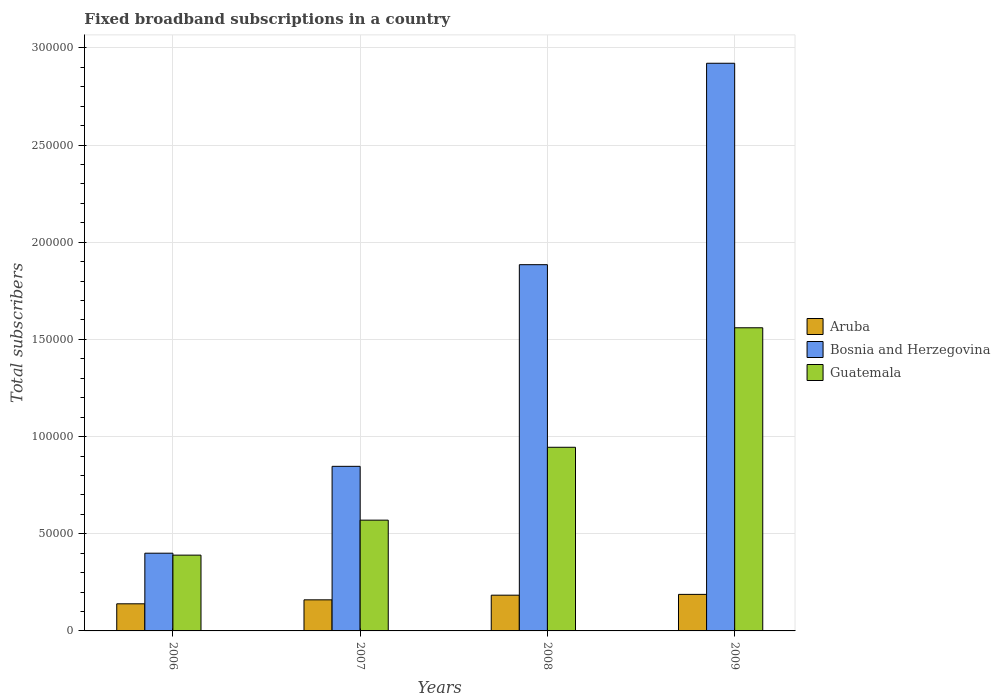How many different coloured bars are there?
Make the answer very short. 3. What is the label of the 4th group of bars from the left?
Offer a very short reply. 2009. In how many cases, is the number of bars for a given year not equal to the number of legend labels?
Keep it short and to the point. 0. What is the number of broadband subscriptions in Aruba in 2008?
Give a very brief answer. 1.84e+04. Across all years, what is the maximum number of broadband subscriptions in Aruba?
Your answer should be very brief. 1.88e+04. Across all years, what is the minimum number of broadband subscriptions in Aruba?
Provide a succinct answer. 1.40e+04. In which year was the number of broadband subscriptions in Aruba maximum?
Your answer should be very brief. 2009. In which year was the number of broadband subscriptions in Guatemala minimum?
Give a very brief answer. 2006. What is the total number of broadband subscriptions in Bosnia and Herzegovina in the graph?
Make the answer very short. 6.05e+05. What is the difference between the number of broadband subscriptions in Bosnia and Herzegovina in 2006 and that in 2007?
Make the answer very short. -4.47e+04. What is the difference between the number of broadband subscriptions in Aruba in 2009 and the number of broadband subscriptions in Bosnia and Herzegovina in 2006?
Your answer should be very brief. -2.12e+04. What is the average number of broadband subscriptions in Guatemala per year?
Ensure brevity in your answer.  8.66e+04. In the year 2009, what is the difference between the number of broadband subscriptions in Bosnia and Herzegovina and number of broadband subscriptions in Guatemala?
Keep it short and to the point. 1.36e+05. What is the ratio of the number of broadband subscriptions in Bosnia and Herzegovina in 2006 to that in 2007?
Your response must be concise. 0.47. What is the difference between the highest and the second highest number of broadband subscriptions in Guatemala?
Your answer should be compact. 6.15e+04. What is the difference between the highest and the lowest number of broadband subscriptions in Bosnia and Herzegovina?
Ensure brevity in your answer.  2.52e+05. What does the 1st bar from the left in 2009 represents?
Offer a very short reply. Aruba. What does the 3rd bar from the right in 2007 represents?
Your answer should be very brief. Aruba. How many bars are there?
Offer a very short reply. 12. Are all the bars in the graph horizontal?
Ensure brevity in your answer.  No. How many years are there in the graph?
Offer a terse response. 4. Are the values on the major ticks of Y-axis written in scientific E-notation?
Keep it short and to the point. No. How are the legend labels stacked?
Make the answer very short. Vertical. What is the title of the graph?
Your answer should be compact. Fixed broadband subscriptions in a country. Does "Jamaica" appear as one of the legend labels in the graph?
Your answer should be compact. No. What is the label or title of the X-axis?
Ensure brevity in your answer.  Years. What is the label or title of the Y-axis?
Offer a very short reply. Total subscribers. What is the Total subscribers of Aruba in 2006?
Provide a succinct answer. 1.40e+04. What is the Total subscribers of Bosnia and Herzegovina in 2006?
Your answer should be compact. 4.00e+04. What is the Total subscribers of Guatemala in 2006?
Your response must be concise. 3.90e+04. What is the Total subscribers of Aruba in 2007?
Make the answer very short. 1.60e+04. What is the Total subscribers of Bosnia and Herzegovina in 2007?
Offer a very short reply. 8.47e+04. What is the Total subscribers of Guatemala in 2007?
Make the answer very short. 5.70e+04. What is the Total subscribers in Aruba in 2008?
Keep it short and to the point. 1.84e+04. What is the Total subscribers in Bosnia and Herzegovina in 2008?
Your answer should be compact. 1.88e+05. What is the Total subscribers of Guatemala in 2008?
Give a very brief answer. 9.45e+04. What is the Total subscribers in Aruba in 2009?
Ensure brevity in your answer.  1.88e+04. What is the Total subscribers in Bosnia and Herzegovina in 2009?
Offer a very short reply. 2.92e+05. What is the Total subscribers of Guatemala in 2009?
Offer a very short reply. 1.56e+05. Across all years, what is the maximum Total subscribers of Aruba?
Ensure brevity in your answer.  1.88e+04. Across all years, what is the maximum Total subscribers in Bosnia and Herzegovina?
Ensure brevity in your answer.  2.92e+05. Across all years, what is the maximum Total subscribers of Guatemala?
Your answer should be compact. 1.56e+05. Across all years, what is the minimum Total subscribers in Aruba?
Offer a very short reply. 1.40e+04. Across all years, what is the minimum Total subscribers of Bosnia and Herzegovina?
Give a very brief answer. 4.00e+04. Across all years, what is the minimum Total subscribers in Guatemala?
Provide a succinct answer. 3.90e+04. What is the total Total subscribers in Aruba in the graph?
Give a very brief answer. 6.71e+04. What is the total Total subscribers in Bosnia and Herzegovina in the graph?
Ensure brevity in your answer.  6.05e+05. What is the total Total subscribers in Guatemala in the graph?
Provide a succinct answer. 3.46e+05. What is the difference between the Total subscribers in Aruba in 2006 and that in 2007?
Keep it short and to the point. -2043. What is the difference between the Total subscribers of Bosnia and Herzegovina in 2006 and that in 2007?
Provide a short and direct response. -4.47e+04. What is the difference between the Total subscribers of Guatemala in 2006 and that in 2007?
Your response must be concise. -1.80e+04. What is the difference between the Total subscribers in Aruba in 2006 and that in 2008?
Make the answer very short. -4443. What is the difference between the Total subscribers of Bosnia and Herzegovina in 2006 and that in 2008?
Keep it short and to the point. -1.48e+05. What is the difference between the Total subscribers in Guatemala in 2006 and that in 2008?
Your response must be concise. -5.55e+04. What is the difference between the Total subscribers of Aruba in 2006 and that in 2009?
Offer a terse response. -4847. What is the difference between the Total subscribers in Bosnia and Herzegovina in 2006 and that in 2009?
Offer a very short reply. -2.52e+05. What is the difference between the Total subscribers of Guatemala in 2006 and that in 2009?
Offer a terse response. -1.17e+05. What is the difference between the Total subscribers in Aruba in 2007 and that in 2008?
Your answer should be very brief. -2400. What is the difference between the Total subscribers of Bosnia and Herzegovina in 2007 and that in 2008?
Your response must be concise. -1.04e+05. What is the difference between the Total subscribers of Guatemala in 2007 and that in 2008?
Offer a very short reply. -3.75e+04. What is the difference between the Total subscribers in Aruba in 2007 and that in 2009?
Your answer should be compact. -2804. What is the difference between the Total subscribers in Bosnia and Herzegovina in 2007 and that in 2009?
Make the answer very short. -2.07e+05. What is the difference between the Total subscribers in Guatemala in 2007 and that in 2009?
Offer a very short reply. -9.90e+04. What is the difference between the Total subscribers of Aruba in 2008 and that in 2009?
Your response must be concise. -404. What is the difference between the Total subscribers in Bosnia and Herzegovina in 2008 and that in 2009?
Give a very brief answer. -1.04e+05. What is the difference between the Total subscribers of Guatemala in 2008 and that in 2009?
Provide a short and direct response. -6.15e+04. What is the difference between the Total subscribers of Aruba in 2006 and the Total subscribers of Bosnia and Herzegovina in 2007?
Your answer should be compact. -7.07e+04. What is the difference between the Total subscribers in Aruba in 2006 and the Total subscribers in Guatemala in 2007?
Provide a short and direct response. -4.30e+04. What is the difference between the Total subscribers of Bosnia and Herzegovina in 2006 and the Total subscribers of Guatemala in 2007?
Give a very brief answer. -1.70e+04. What is the difference between the Total subscribers of Aruba in 2006 and the Total subscribers of Bosnia and Herzegovina in 2008?
Offer a terse response. -1.75e+05. What is the difference between the Total subscribers of Aruba in 2006 and the Total subscribers of Guatemala in 2008?
Give a very brief answer. -8.05e+04. What is the difference between the Total subscribers of Bosnia and Herzegovina in 2006 and the Total subscribers of Guatemala in 2008?
Offer a terse response. -5.45e+04. What is the difference between the Total subscribers of Aruba in 2006 and the Total subscribers of Bosnia and Herzegovina in 2009?
Ensure brevity in your answer.  -2.78e+05. What is the difference between the Total subscribers of Aruba in 2006 and the Total subscribers of Guatemala in 2009?
Provide a short and direct response. -1.42e+05. What is the difference between the Total subscribers of Bosnia and Herzegovina in 2006 and the Total subscribers of Guatemala in 2009?
Provide a short and direct response. -1.16e+05. What is the difference between the Total subscribers of Aruba in 2007 and the Total subscribers of Bosnia and Herzegovina in 2008?
Offer a very short reply. -1.72e+05. What is the difference between the Total subscribers in Aruba in 2007 and the Total subscribers in Guatemala in 2008?
Offer a terse response. -7.85e+04. What is the difference between the Total subscribers in Bosnia and Herzegovina in 2007 and the Total subscribers in Guatemala in 2008?
Offer a very short reply. -9809. What is the difference between the Total subscribers in Aruba in 2007 and the Total subscribers in Bosnia and Herzegovina in 2009?
Offer a very short reply. -2.76e+05. What is the difference between the Total subscribers in Aruba in 2007 and the Total subscribers in Guatemala in 2009?
Your answer should be very brief. -1.40e+05. What is the difference between the Total subscribers in Bosnia and Herzegovina in 2007 and the Total subscribers in Guatemala in 2009?
Your response must be concise. -7.13e+04. What is the difference between the Total subscribers in Aruba in 2008 and the Total subscribers in Bosnia and Herzegovina in 2009?
Keep it short and to the point. -2.74e+05. What is the difference between the Total subscribers in Aruba in 2008 and the Total subscribers in Guatemala in 2009?
Your answer should be compact. -1.38e+05. What is the difference between the Total subscribers in Bosnia and Herzegovina in 2008 and the Total subscribers in Guatemala in 2009?
Offer a terse response. 3.25e+04. What is the average Total subscribers of Aruba per year?
Ensure brevity in your answer.  1.68e+04. What is the average Total subscribers of Bosnia and Herzegovina per year?
Ensure brevity in your answer.  1.51e+05. What is the average Total subscribers in Guatemala per year?
Your response must be concise. 8.66e+04. In the year 2006, what is the difference between the Total subscribers in Aruba and Total subscribers in Bosnia and Herzegovina?
Give a very brief answer. -2.60e+04. In the year 2006, what is the difference between the Total subscribers in Aruba and Total subscribers in Guatemala?
Offer a very short reply. -2.50e+04. In the year 2007, what is the difference between the Total subscribers in Aruba and Total subscribers in Bosnia and Herzegovina?
Your answer should be very brief. -6.87e+04. In the year 2007, what is the difference between the Total subscribers in Aruba and Total subscribers in Guatemala?
Keep it short and to the point. -4.10e+04. In the year 2007, what is the difference between the Total subscribers in Bosnia and Herzegovina and Total subscribers in Guatemala?
Offer a very short reply. 2.77e+04. In the year 2008, what is the difference between the Total subscribers of Aruba and Total subscribers of Bosnia and Herzegovina?
Offer a terse response. -1.70e+05. In the year 2008, what is the difference between the Total subscribers in Aruba and Total subscribers in Guatemala?
Your answer should be compact. -7.61e+04. In the year 2008, what is the difference between the Total subscribers of Bosnia and Herzegovina and Total subscribers of Guatemala?
Provide a short and direct response. 9.40e+04. In the year 2009, what is the difference between the Total subscribers in Aruba and Total subscribers in Bosnia and Herzegovina?
Offer a terse response. -2.73e+05. In the year 2009, what is the difference between the Total subscribers of Aruba and Total subscribers of Guatemala?
Your response must be concise. -1.37e+05. In the year 2009, what is the difference between the Total subscribers of Bosnia and Herzegovina and Total subscribers of Guatemala?
Ensure brevity in your answer.  1.36e+05. What is the ratio of the Total subscribers of Aruba in 2006 to that in 2007?
Your answer should be compact. 0.87. What is the ratio of the Total subscribers of Bosnia and Herzegovina in 2006 to that in 2007?
Ensure brevity in your answer.  0.47. What is the ratio of the Total subscribers in Guatemala in 2006 to that in 2007?
Provide a short and direct response. 0.68. What is the ratio of the Total subscribers of Aruba in 2006 to that in 2008?
Provide a short and direct response. 0.76. What is the ratio of the Total subscribers of Bosnia and Herzegovina in 2006 to that in 2008?
Make the answer very short. 0.21. What is the ratio of the Total subscribers in Guatemala in 2006 to that in 2008?
Keep it short and to the point. 0.41. What is the ratio of the Total subscribers in Aruba in 2006 to that in 2009?
Your response must be concise. 0.74. What is the ratio of the Total subscribers in Bosnia and Herzegovina in 2006 to that in 2009?
Offer a terse response. 0.14. What is the ratio of the Total subscribers in Guatemala in 2006 to that in 2009?
Ensure brevity in your answer.  0.25. What is the ratio of the Total subscribers in Aruba in 2007 to that in 2008?
Make the answer very short. 0.87. What is the ratio of the Total subscribers in Bosnia and Herzegovina in 2007 to that in 2008?
Give a very brief answer. 0.45. What is the ratio of the Total subscribers in Guatemala in 2007 to that in 2008?
Ensure brevity in your answer.  0.6. What is the ratio of the Total subscribers of Aruba in 2007 to that in 2009?
Ensure brevity in your answer.  0.85. What is the ratio of the Total subscribers of Bosnia and Herzegovina in 2007 to that in 2009?
Offer a terse response. 0.29. What is the ratio of the Total subscribers of Guatemala in 2007 to that in 2009?
Offer a terse response. 0.37. What is the ratio of the Total subscribers of Aruba in 2008 to that in 2009?
Offer a very short reply. 0.98. What is the ratio of the Total subscribers in Bosnia and Herzegovina in 2008 to that in 2009?
Offer a very short reply. 0.65. What is the ratio of the Total subscribers in Guatemala in 2008 to that in 2009?
Your response must be concise. 0.61. What is the difference between the highest and the second highest Total subscribers of Aruba?
Give a very brief answer. 404. What is the difference between the highest and the second highest Total subscribers in Bosnia and Herzegovina?
Give a very brief answer. 1.04e+05. What is the difference between the highest and the second highest Total subscribers in Guatemala?
Offer a very short reply. 6.15e+04. What is the difference between the highest and the lowest Total subscribers in Aruba?
Provide a succinct answer. 4847. What is the difference between the highest and the lowest Total subscribers of Bosnia and Herzegovina?
Provide a succinct answer. 2.52e+05. What is the difference between the highest and the lowest Total subscribers in Guatemala?
Give a very brief answer. 1.17e+05. 